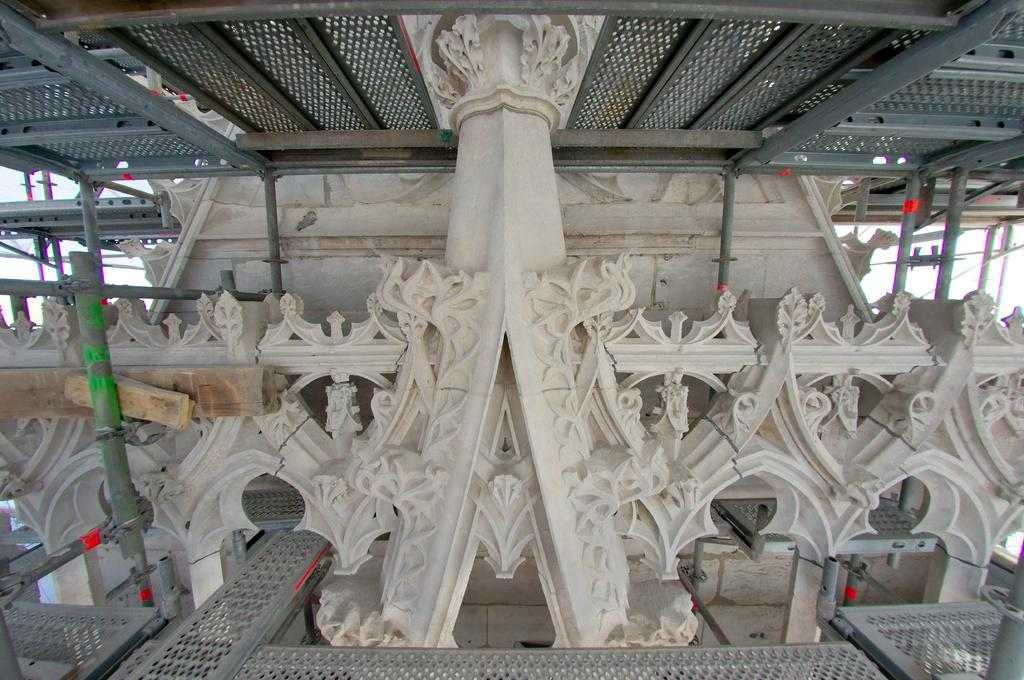What type of material is present in the image? There is plywood in the image. What other objects can be seen in the image? There are poles in the image. What can be seen at the top of the roof in the image? There are metal rods visible at the top of the roof in the image. What type of soap is being used to clean the plywood in the image? There is no soap present in the image, and the plywood is not being cleaned. Is there a gate visible in the image? There is no gate present in the image. 